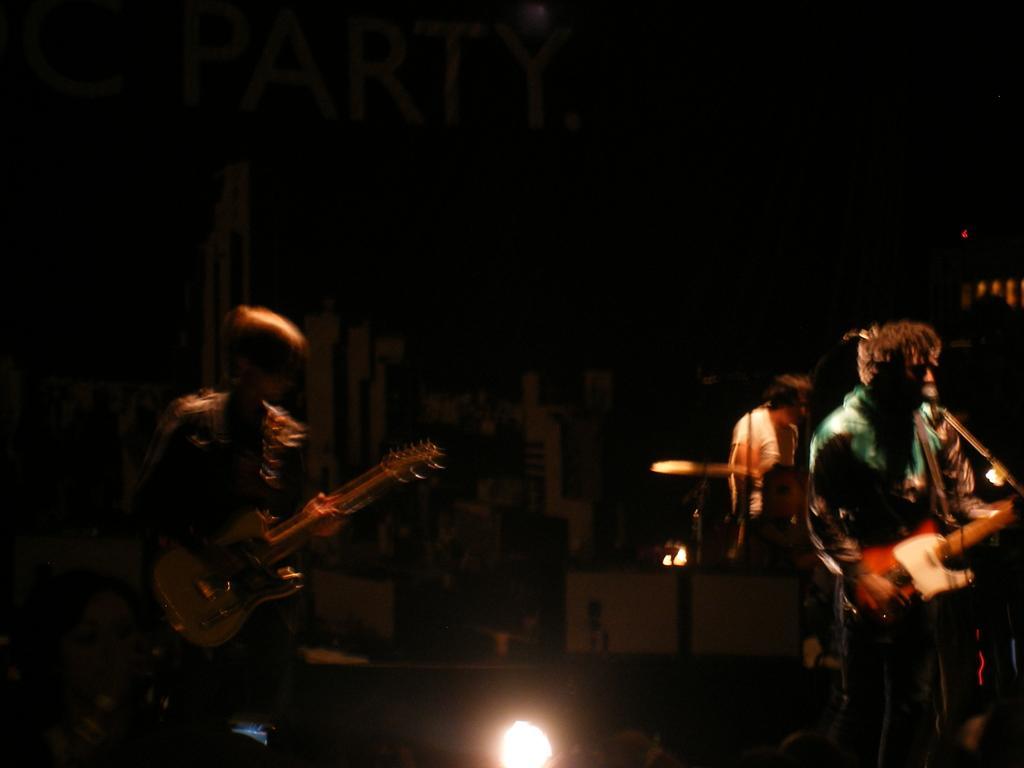Describe this image in one or two sentences. In the image we can see there are people who are standing and they are holding guitar in their hand. 